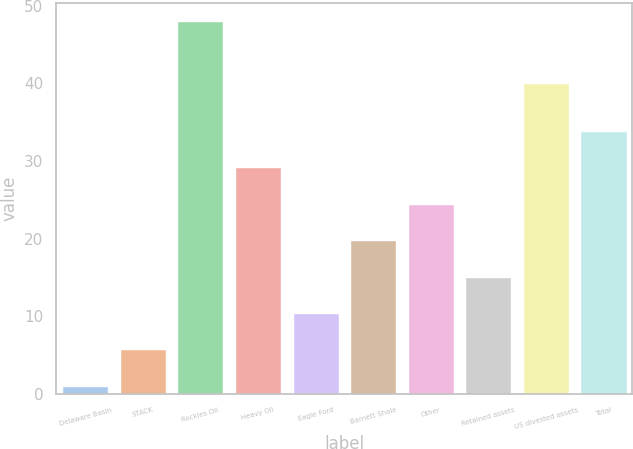Convert chart to OTSL. <chart><loc_0><loc_0><loc_500><loc_500><bar_chart><fcel>Delaware Basin<fcel>STACK<fcel>Rockies Oil<fcel>Heavy Oil<fcel>Eagle Ford<fcel>Barnett Shale<fcel>Other<fcel>Retained assets<fcel>US divested assets<fcel>Total<nl><fcel>1<fcel>5.7<fcel>48<fcel>29.2<fcel>10.4<fcel>19.8<fcel>24.5<fcel>15.1<fcel>40<fcel>33.9<nl></chart> 